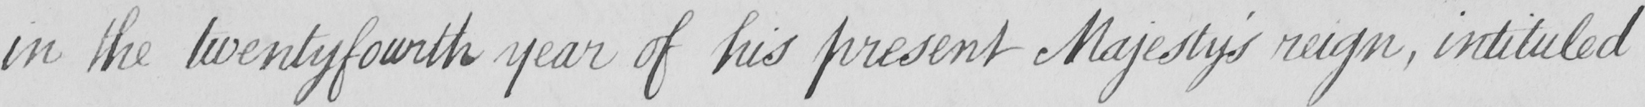Can you read and transcribe this handwriting? in the twentyfourth year of his present Majesty ' s reign , intituled 